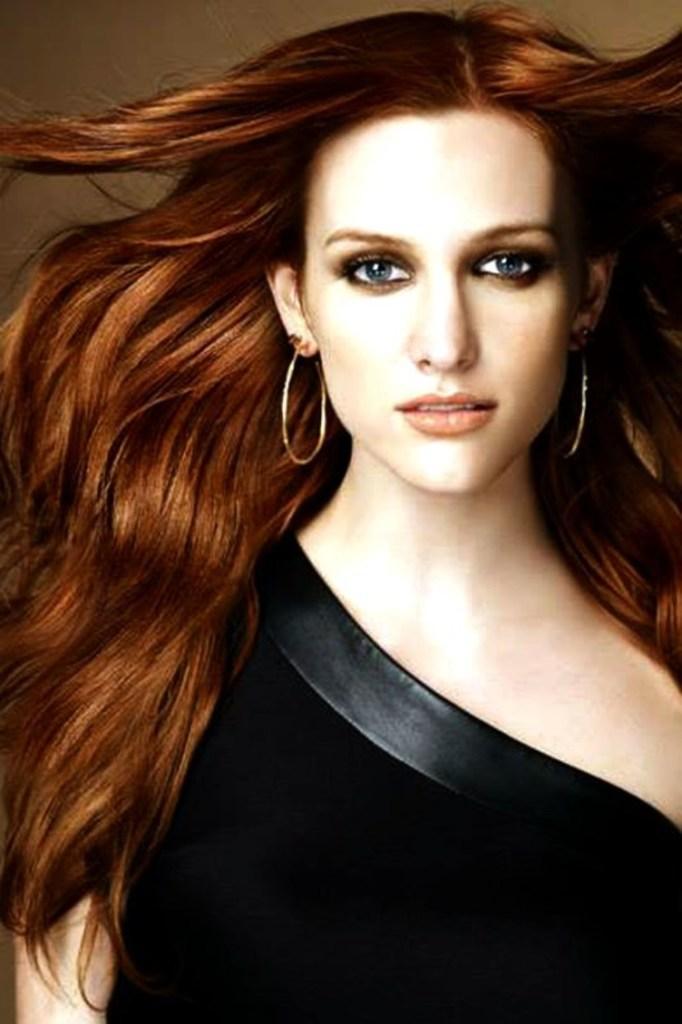How would you summarize this image in a sentence or two? There is a woman wore black dress,behind this woman it is brown color. 